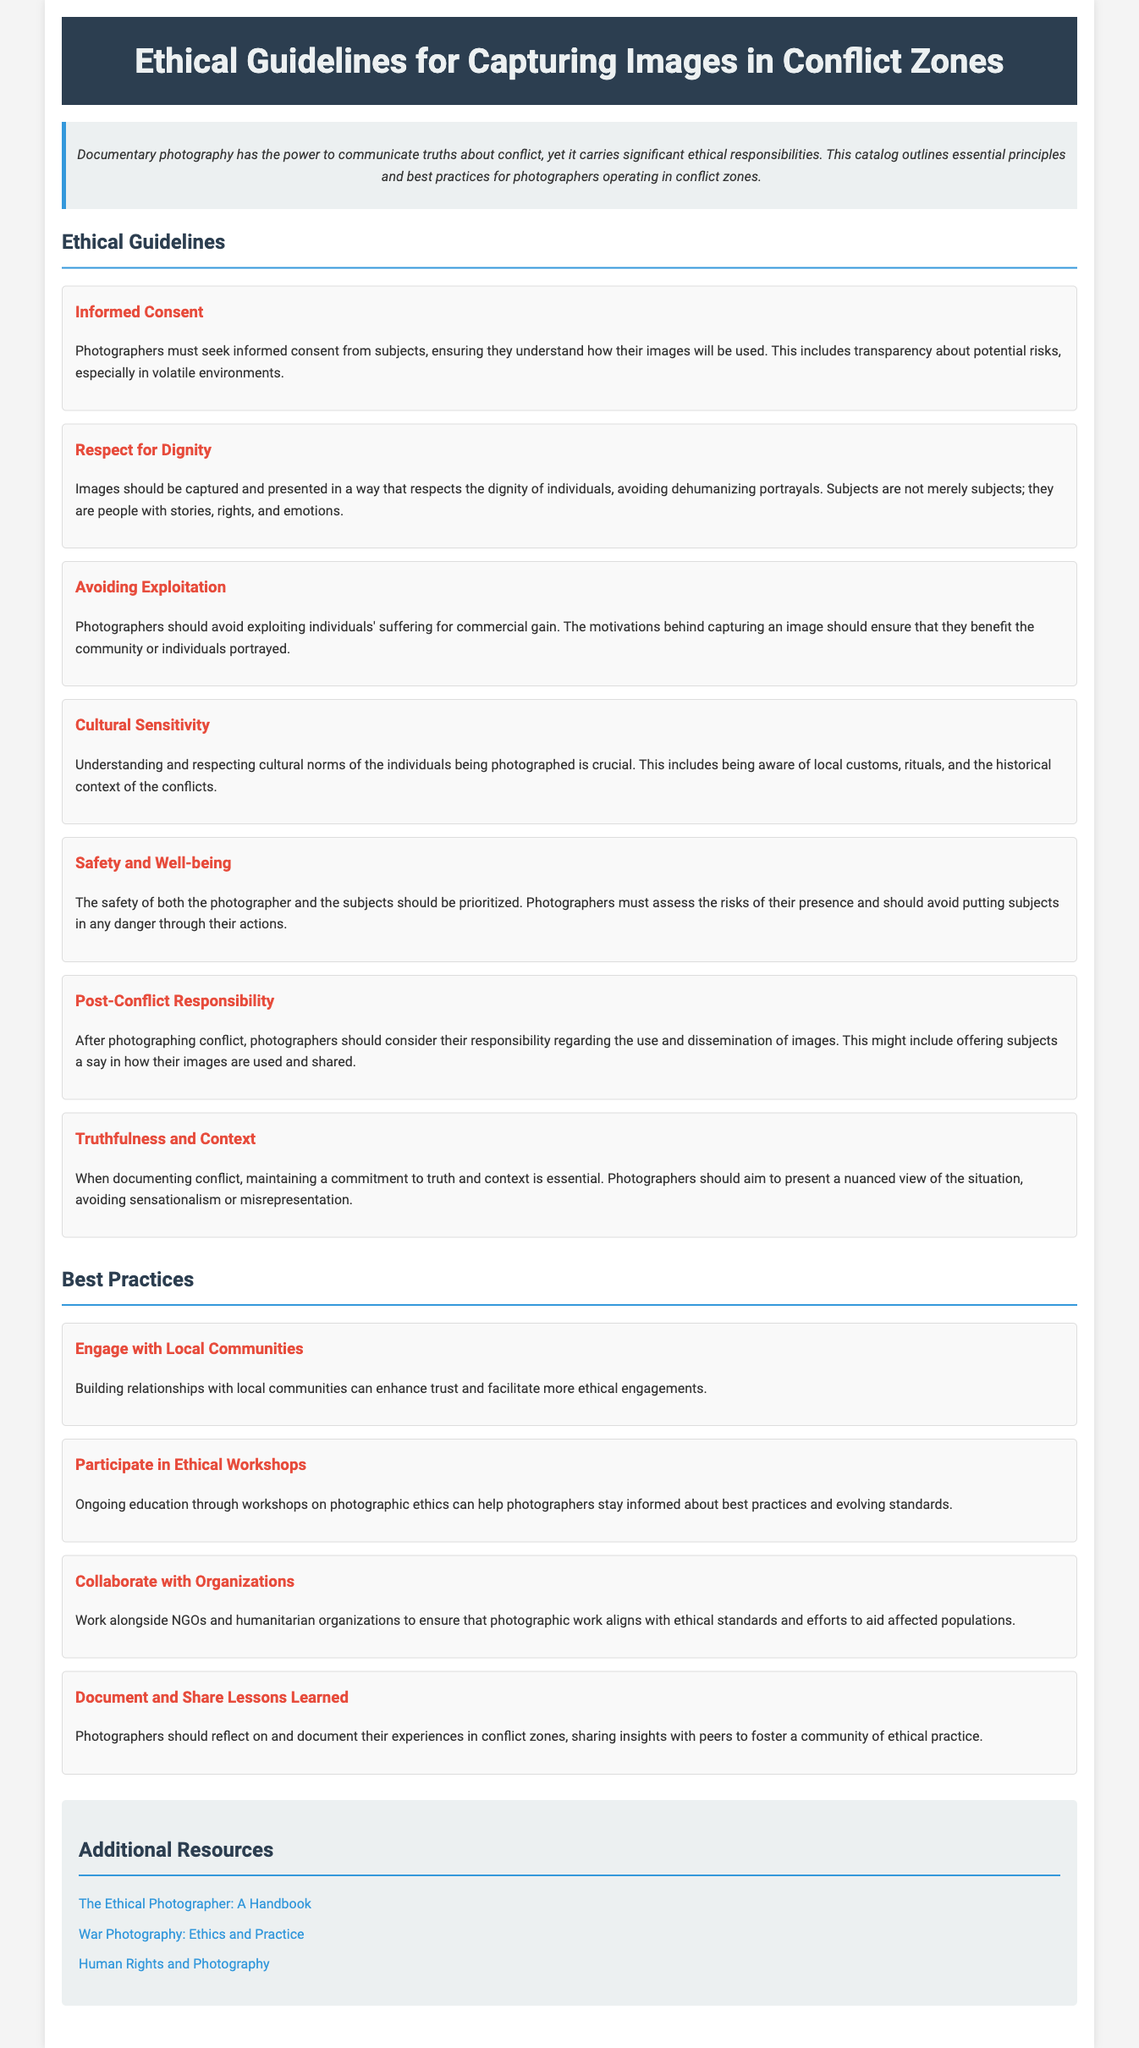What is the title of the document? The title of the document is specified in the header section.
Answer: Ethical Guidelines for Capturing Images in Conflict Zones How many ethical guidelines are outlined in the document? The document lists the number of ethical guidelines under the section header.
Answer: Seven What should photographers prioritize according to safety and well-being? The guideline emphasizes the importance of safety for both photographers and subjects.
Answer: Safety What is emphasized as crucial when photographing individuals? The guideline elaborates on the treatment of individuals being photographed within the ethical standards.
Answer: Respect for Dignity What is a suggested best practice for photographers in conflict zones? The best practice sections provide actionable advice for ethical conduct in photography.
Answer: Engage with Local Communities What type of responsibility do photographers have after capturing conflict images? The document outlines responsibilities photographers should consider after photographing conflict situations.
Answer: Post-Conflict Responsibility What is the color of the header background? The style section of the document specifies the visual theme including colors.
Answer: Dark blue What should photographers ensure regarding image use? This principle addresses the importance of transparency and consent in the ethical use of images.
Answer: Informed Consent Which additional resource is provided for photographers? The document lists external resources for further reading on photographic ethics.
Answer: The Ethical Photographer: A Handbook 